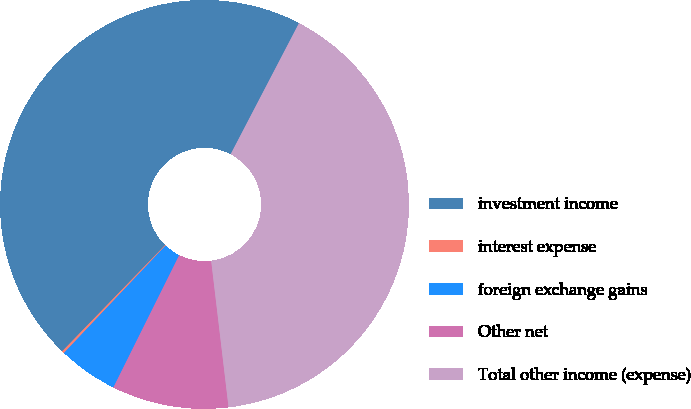Convert chart to OTSL. <chart><loc_0><loc_0><loc_500><loc_500><pie_chart><fcel>investment income<fcel>interest expense<fcel>foreign exchange gains<fcel>Other net<fcel>Total other income (expense)<nl><fcel>45.4%<fcel>0.19%<fcel>4.71%<fcel>9.23%<fcel>40.47%<nl></chart> 